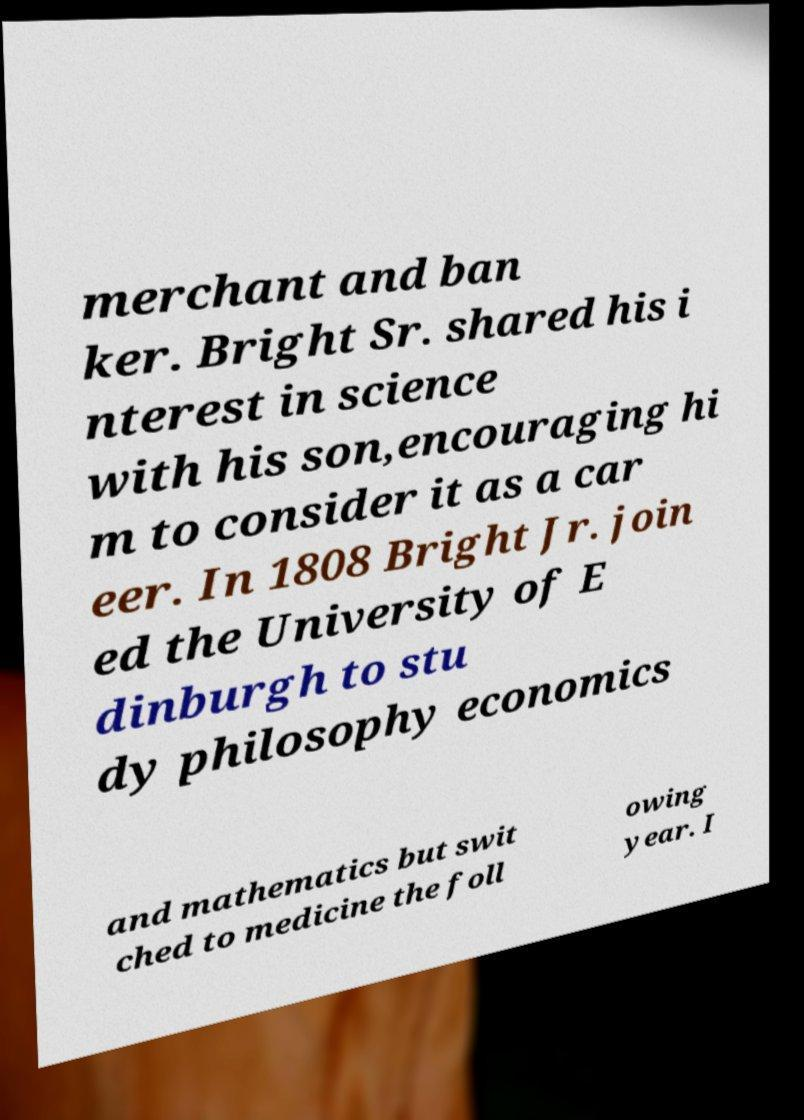Can you read and provide the text displayed in the image?This photo seems to have some interesting text. Can you extract and type it out for me? merchant and ban ker. Bright Sr. shared his i nterest in science with his son,encouraging hi m to consider it as a car eer. In 1808 Bright Jr. join ed the University of E dinburgh to stu dy philosophy economics and mathematics but swit ched to medicine the foll owing year. I 